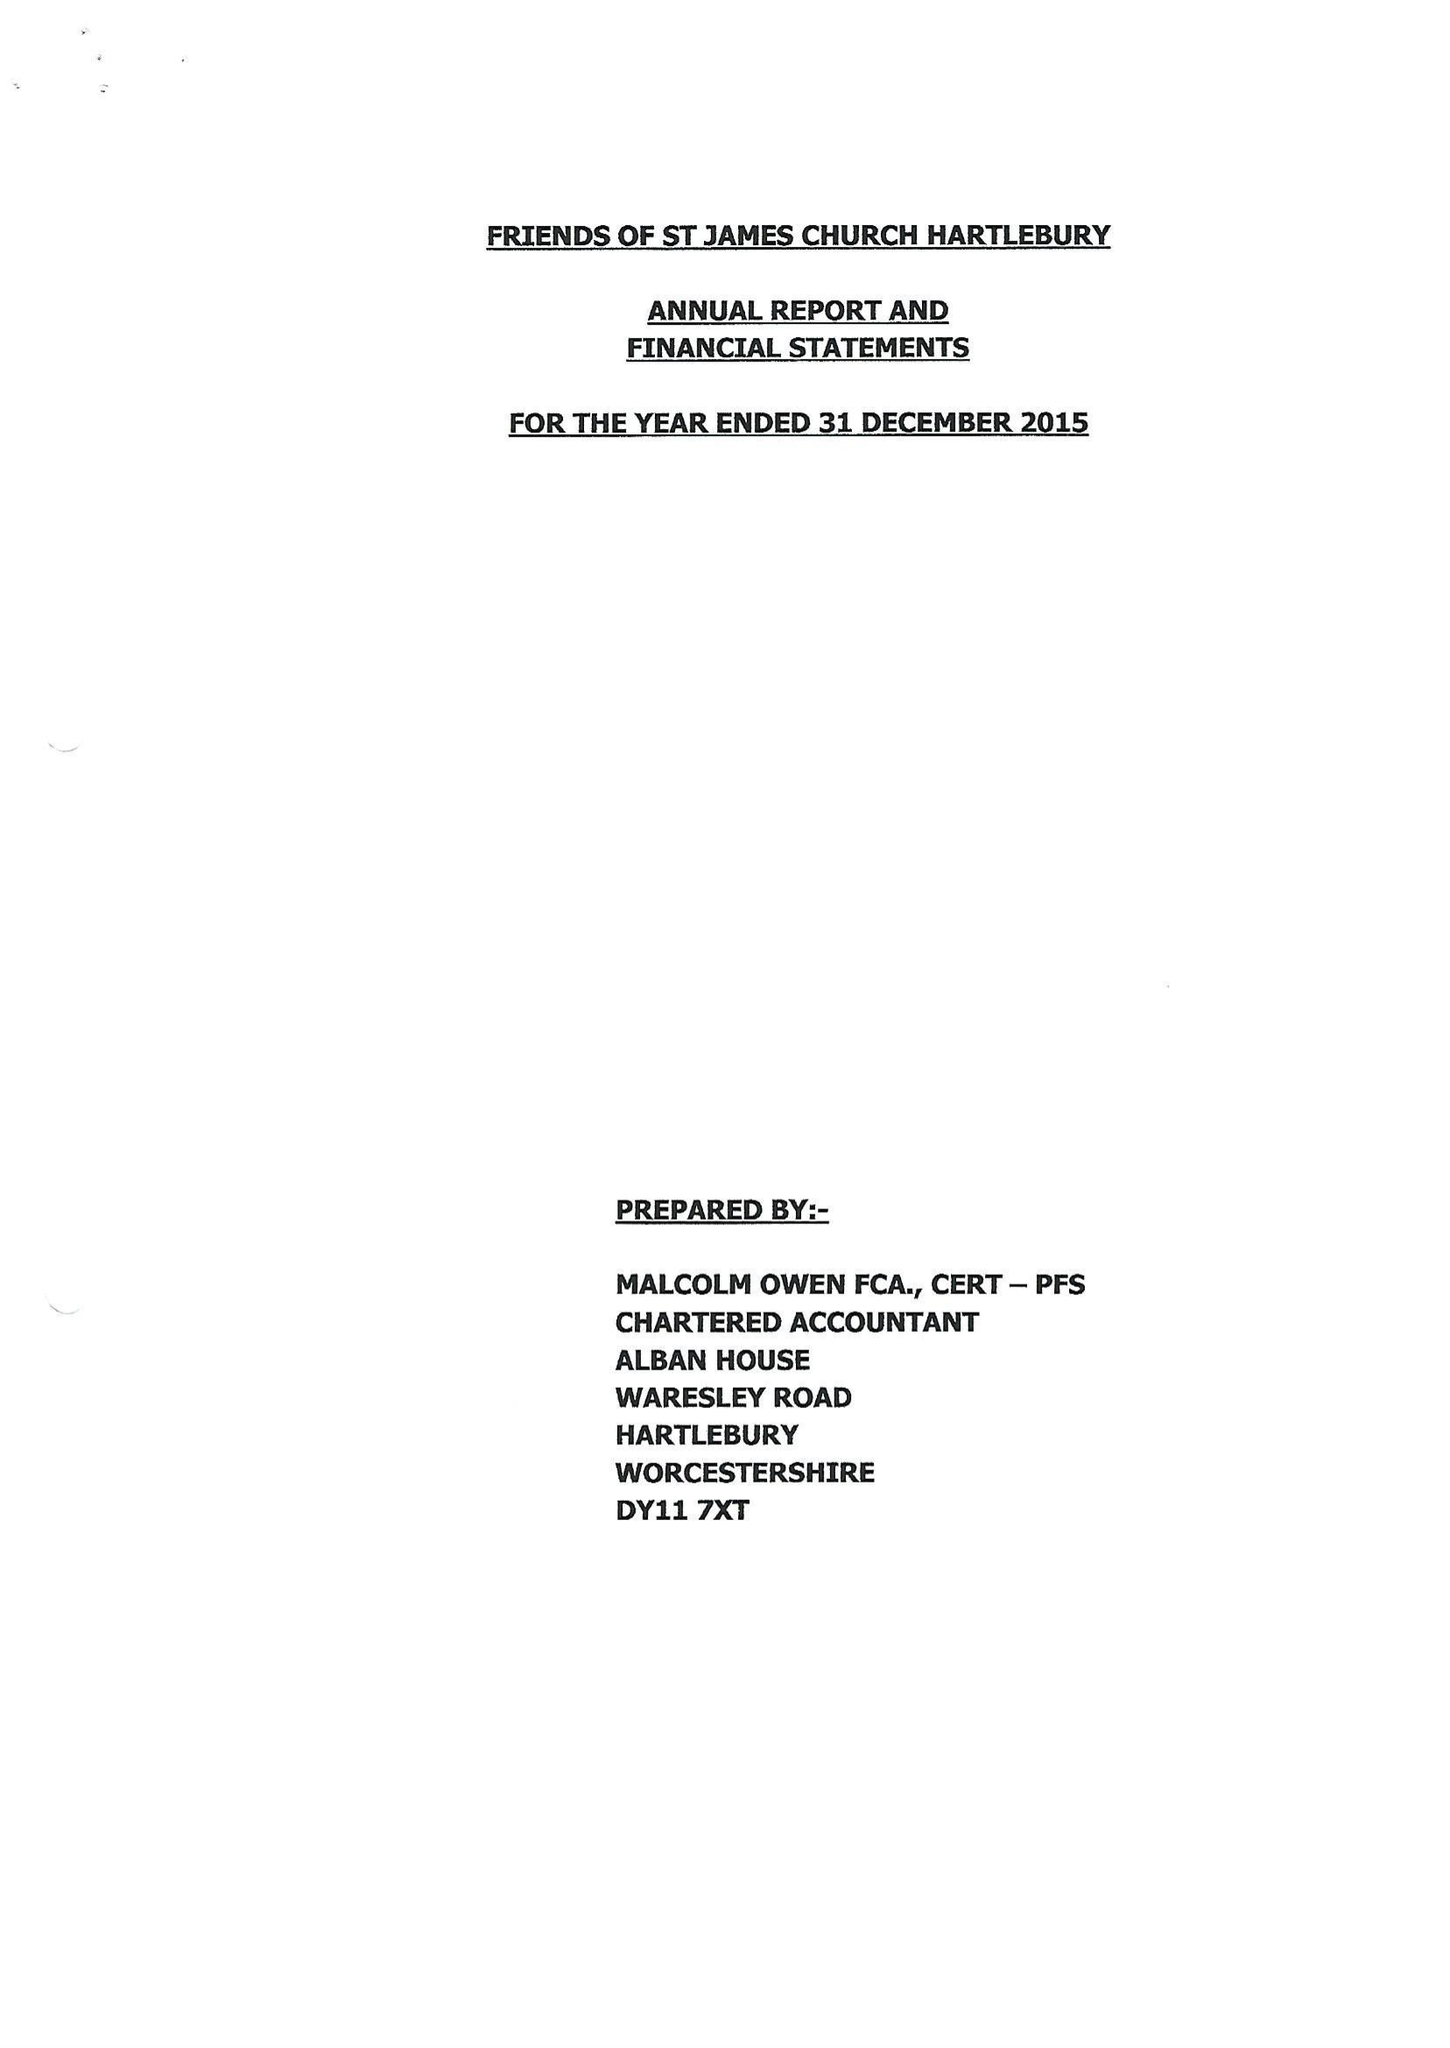What is the value for the address__postcode?
Answer the question using a single word or phrase. DY11 7XT 